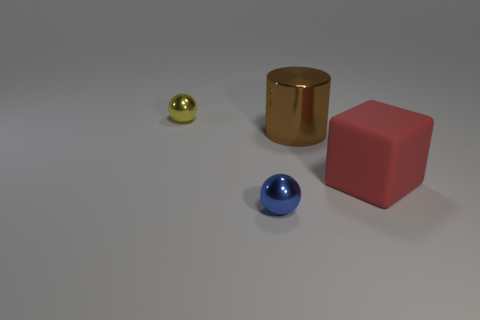Add 1 big cyan objects. How many objects exist? 5 Subtract all blocks. How many objects are left? 3 Subtract all blocks. Subtract all yellow objects. How many objects are left? 2 Add 2 big rubber objects. How many big rubber objects are left? 3 Add 3 big shiny cylinders. How many big shiny cylinders exist? 4 Subtract 0 gray blocks. How many objects are left? 4 